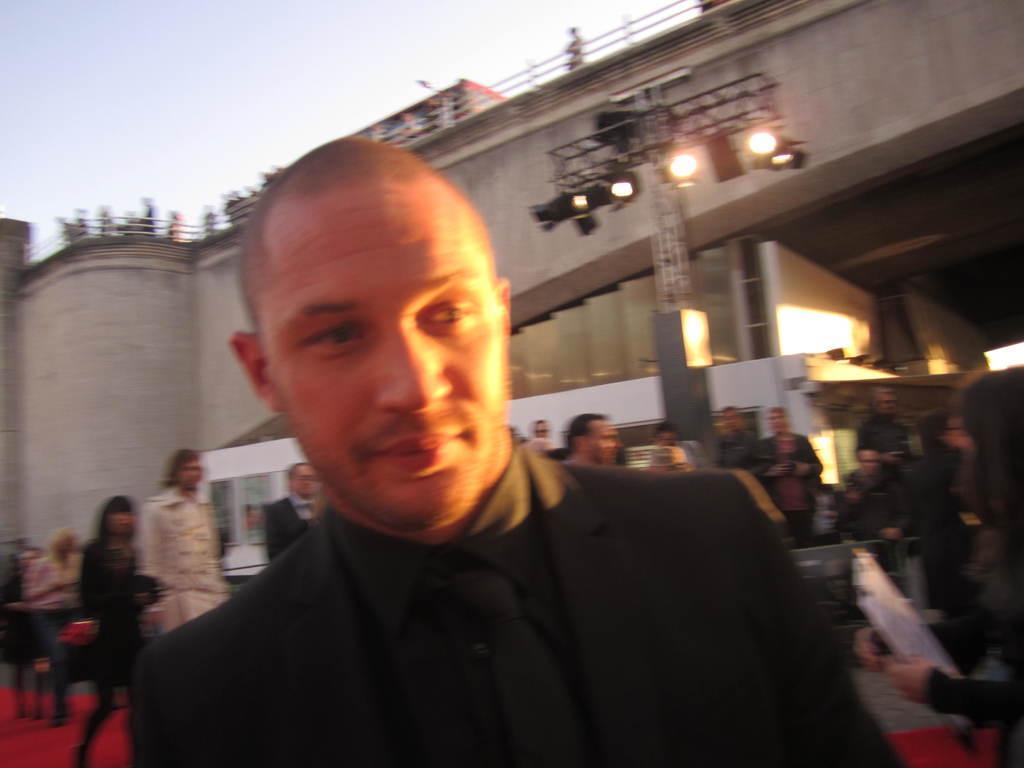In one or two sentences, can you explain what this image depicts? In this image we can see a person wearing black color dress and at the background of the image there are some persons standing, walking there are some lights and bridge. 